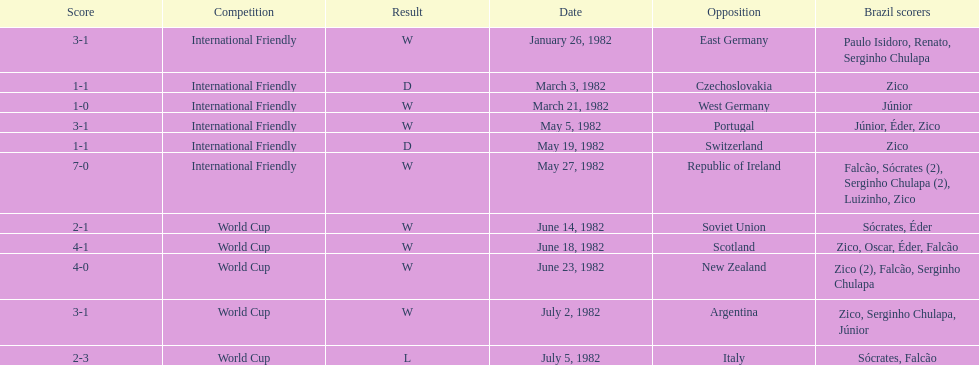Did brazil score more goals against the soviet union or portugal in 1982? Portugal. 